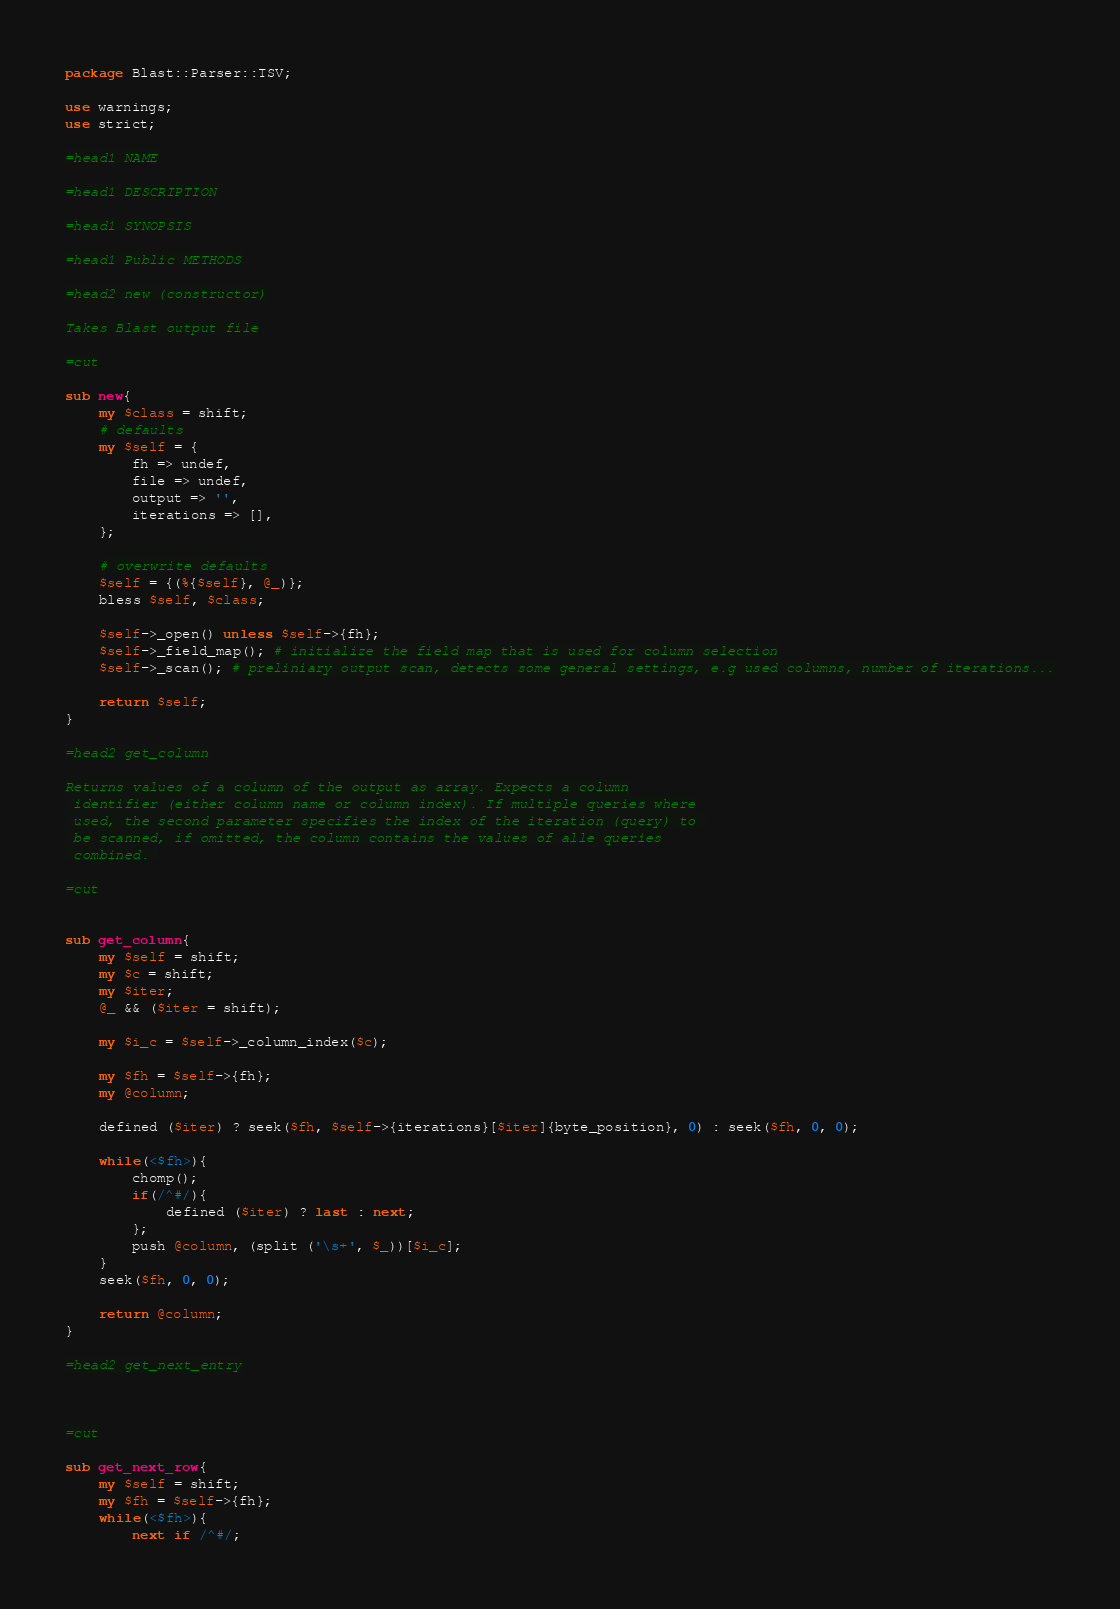<code> <loc_0><loc_0><loc_500><loc_500><_Perl_>package Blast::Parser::TSV;

use warnings;
use strict;

=head1 NAME

=head1 DESCRIPTION

=head1 SYNOPSIS

=head1 Public METHODS

=head2 new (constructor)

Takes Blast output file

=cut

sub new{
	my $class = shift;
	# defaults
	my $self = {
		fh => undef,
		file => undef,
		output => '',
		iterations => [],
	};
	
	# overwrite defaults
	$self = {(%{$self}, @_)};
    bless $self, $class;	
	
	$self->_open() unless $self->{fh};
	$self->_field_map(); # initialize the field map that is used for column selection
	$self->_scan(); # preliniary output scan, detects some general settings, e.g used columns, number of iterations...
	
    return $self;
}

=head2 get_column

Returns values of a column of the output as array. Expects a column
 identifier (either column name or column index). If multiple queries where
 used, the second parameter specifies the index of the iteration (query) to 
 be scanned, if omitted, the column contains the values of alle queries
 combined. 

=cut


sub get_column{
	my $self = shift;
	my $c = shift;
	my $iter;
	@_ && ($iter = shift);
	
	my $i_c = $self->_column_index($c);

	my $fh = $self->{fh};
	my @column;
	
	defined ($iter) ? seek($fh, $self->{iterations}[$iter]{byte_position}, 0) : seek($fh, 0, 0);
	
	while(<$fh>){
		chomp();
		if(/^#/){
			defined ($iter) ? last : next;
		};
		push @column, (split ('\s+', $_))[$i_c];
	}
	seek($fh, 0, 0);
	
	return @column;
}

=head2 get_next_entry



=cut

sub get_next_row{
	my $self = shift;
	my $fh = $self->{fh};
	while(<$fh>){
		next if /^#/;</code> 